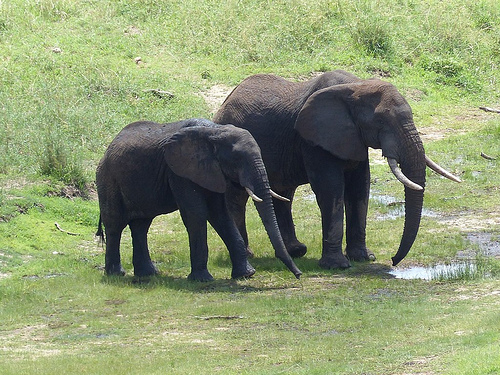What kind of animal is the hill behind of, an elephant or a giraffe? The hill is behind an elephant, as seen clearly in the image. 